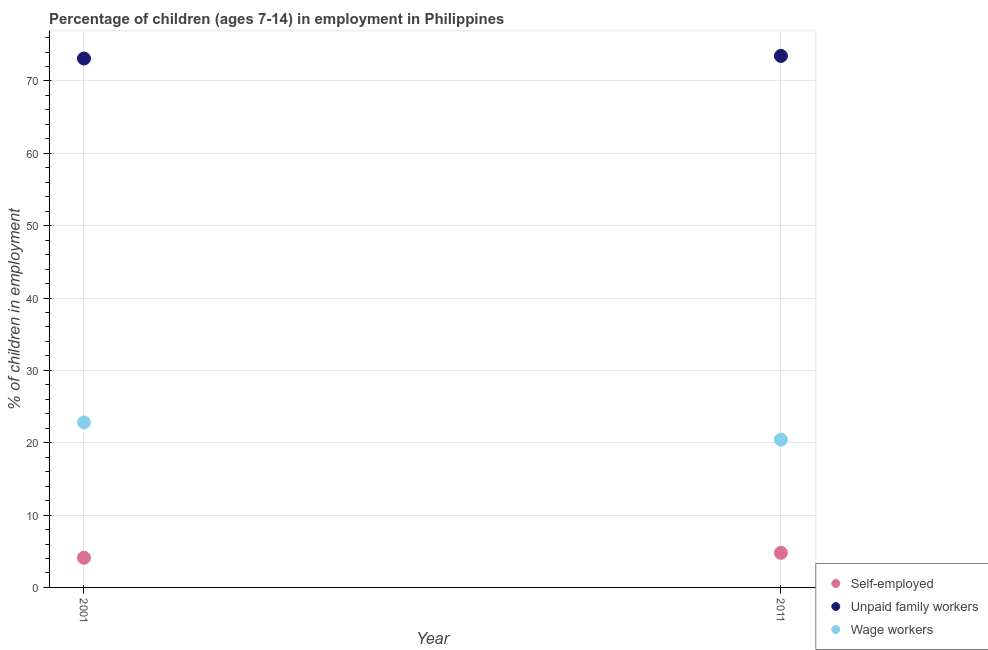How many different coloured dotlines are there?
Offer a very short reply. 3. What is the percentage of children employed as unpaid family workers in 2011?
Ensure brevity in your answer.  73.46. Across all years, what is the maximum percentage of children employed as unpaid family workers?
Provide a succinct answer. 73.46. Across all years, what is the minimum percentage of children employed as wage workers?
Your answer should be very brief. 20.42. In which year was the percentage of children employed as wage workers minimum?
Your answer should be compact. 2011. What is the total percentage of children employed as unpaid family workers in the graph?
Provide a succinct answer. 146.56. What is the difference between the percentage of children employed as unpaid family workers in 2001 and that in 2011?
Provide a short and direct response. -0.36. What is the difference between the percentage of children employed as wage workers in 2011 and the percentage of self employed children in 2001?
Ensure brevity in your answer.  16.32. What is the average percentage of self employed children per year?
Make the answer very short. 4.44. In the year 2011, what is the difference between the percentage of children employed as unpaid family workers and percentage of self employed children?
Provide a short and direct response. 68.68. In how many years, is the percentage of children employed as unpaid family workers greater than 28 %?
Offer a very short reply. 2. What is the ratio of the percentage of children employed as wage workers in 2001 to that in 2011?
Your response must be concise. 1.12. Is the percentage of children employed as unpaid family workers in 2001 less than that in 2011?
Your response must be concise. Yes. Is the percentage of children employed as wage workers strictly greater than the percentage of children employed as unpaid family workers over the years?
Provide a succinct answer. No. Is the percentage of children employed as wage workers strictly less than the percentage of self employed children over the years?
Provide a succinct answer. No. How many dotlines are there?
Your answer should be compact. 3. What is the difference between two consecutive major ticks on the Y-axis?
Your answer should be very brief. 10. Are the values on the major ticks of Y-axis written in scientific E-notation?
Your answer should be very brief. No. Does the graph contain grids?
Keep it short and to the point. Yes. Where does the legend appear in the graph?
Your response must be concise. Bottom right. What is the title of the graph?
Your answer should be compact. Percentage of children (ages 7-14) in employment in Philippines. What is the label or title of the X-axis?
Offer a terse response. Year. What is the label or title of the Y-axis?
Offer a very short reply. % of children in employment. What is the % of children in employment of Unpaid family workers in 2001?
Ensure brevity in your answer.  73.1. What is the % of children in employment of Wage workers in 2001?
Make the answer very short. 22.8. What is the % of children in employment in Self-employed in 2011?
Your response must be concise. 4.78. What is the % of children in employment in Unpaid family workers in 2011?
Give a very brief answer. 73.46. What is the % of children in employment of Wage workers in 2011?
Ensure brevity in your answer.  20.42. Across all years, what is the maximum % of children in employment of Self-employed?
Ensure brevity in your answer.  4.78. Across all years, what is the maximum % of children in employment in Unpaid family workers?
Your response must be concise. 73.46. Across all years, what is the maximum % of children in employment of Wage workers?
Your answer should be very brief. 22.8. Across all years, what is the minimum % of children in employment in Unpaid family workers?
Your answer should be compact. 73.1. Across all years, what is the minimum % of children in employment of Wage workers?
Offer a very short reply. 20.42. What is the total % of children in employment of Self-employed in the graph?
Give a very brief answer. 8.88. What is the total % of children in employment in Unpaid family workers in the graph?
Give a very brief answer. 146.56. What is the total % of children in employment of Wage workers in the graph?
Offer a very short reply. 43.22. What is the difference between the % of children in employment of Self-employed in 2001 and that in 2011?
Your response must be concise. -0.68. What is the difference between the % of children in employment in Unpaid family workers in 2001 and that in 2011?
Make the answer very short. -0.36. What is the difference between the % of children in employment of Wage workers in 2001 and that in 2011?
Give a very brief answer. 2.38. What is the difference between the % of children in employment of Self-employed in 2001 and the % of children in employment of Unpaid family workers in 2011?
Offer a terse response. -69.36. What is the difference between the % of children in employment of Self-employed in 2001 and the % of children in employment of Wage workers in 2011?
Offer a very short reply. -16.32. What is the difference between the % of children in employment of Unpaid family workers in 2001 and the % of children in employment of Wage workers in 2011?
Ensure brevity in your answer.  52.68. What is the average % of children in employment in Self-employed per year?
Provide a short and direct response. 4.44. What is the average % of children in employment in Unpaid family workers per year?
Give a very brief answer. 73.28. What is the average % of children in employment in Wage workers per year?
Offer a very short reply. 21.61. In the year 2001, what is the difference between the % of children in employment in Self-employed and % of children in employment in Unpaid family workers?
Keep it short and to the point. -69. In the year 2001, what is the difference between the % of children in employment of Self-employed and % of children in employment of Wage workers?
Your answer should be compact. -18.7. In the year 2001, what is the difference between the % of children in employment in Unpaid family workers and % of children in employment in Wage workers?
Provide a short and direct response. 50.3. In the year 2011, what is the difference between the % of children in employment in Self-employed and % of children in employment in Unpaid family workers?
Provide a succinct answer. -68.68. In the year 2011, what is the difference between the % of children in employment of Self-employed and % of children in employment of Wage workers?
Provide a short and direct response. -15.64. In the year 2011, what is the difference between the % of children in employment in Unpaid family workers and % of children in employment in Wage workers?
Keep it short and to the point. 53.04. What is the ratio of the % of children in employment of Self-employed in 2001 to that in 2011?
Ensure brevity in your answer.  0.86. What is the ratio of the % of children in employment of Wage workers in 2001 to that in 2011?
Give a very brief answer. 1.12. What is the difference between the highest and the second highest % of children in employment in Self-employed?
Your answer should be very brief. 0.68. What is the difference between the highest and the second highest % of children in employment in Unpaid family workers?
Your answer should be compact. 0.36. What is the difference between the highest and the second highest % of children in employment of Wage workers?
Your response must be concise. 2.38. What is the difference between the highest and the lowest % of children in employment in Self-employed?
Offer a very short reply. 0.68. What is the difference between the highest and the lowest % of children in employment of Unpaid family workers?
Offer a very short reply. 0.36. What is the difference between the highest and the lowest % of children in employment of Wage workers?
Offer a terse response. 2.38. 